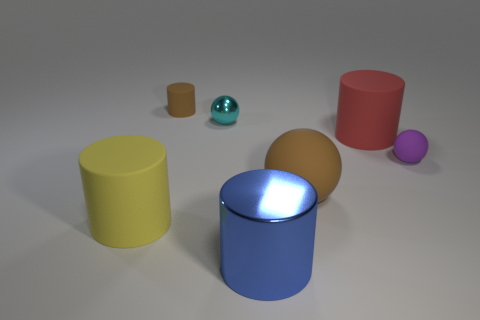Subtract all large yellow cylinders. How many cylinders are left? 3 Add 2 yellow things. How many objects exist? 9 Subtract all spheres. How many objects are left? 4 Subtract all cyan spheres. How many spheres are left? 2 Subtract 1 red cylinders. How many objects are left? 6 Subtract 4 cylinders. How many cylinders are left? 0 Subtract all brown cylinders. Subtract all red balls. How many cylinders are left? 3 Subtract all blue blocks. How many cyan spheres are left? 1 Subtract all purple rubber cylinders. Subtract all large things. How many objects are left? 3 Add 6 brown spheres. How many brown spheres are left? 7 